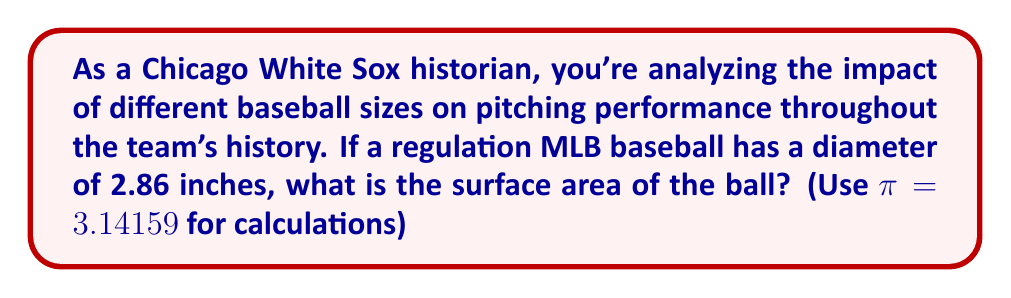Show me your answer to this math problem. To solve this problem, we'll follow these steps:

1) First, recall the formula for the surface area of a sphere:
   $$A = 4πr^2$$
   where $A$ is the surface area and $r$ is the radius of the sphere.

2) We're given the diameter of the baseball, which is 2.86 inches. To find the radius, we divide the diameter by 2:
   $$r = \frac{2.86}{2} = 1.43\text{ inches}$$

3) Now we can substitute this value into our formula:
   $$A = 4π(1.43)^2$$

4) Let's calculate the square of the radius:
   $$1.43^2 = 2.0449$$

5) Now we can simplify our equation:
   $$A = 4 \cdot 3.14159 \cdot 2.0449$$

6) Multiply:
   $$A = 25.6567\text{ square inches}$$

7) Rounding to two decimal places:
   $$A ≈ 25.66\text{ square inches}$$

This surface area represents the total area a pitcher's fingers can grip when throwing the ball, which can affect the types of pitches thrown and their effectiveness.
Answer: $25.66\text{ square inches}$ 